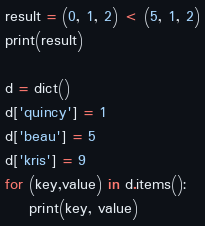<code> <loc_0><loc_0><loc_500><loc_500><_Python_>result = (0, 1, 2) < (5, 1, 2)
print(result)

d = dict()
d['quincy'] = 1
d['beau'] = 5
d['kris'] = 9
for (key,value) in d.items():
    print(key, value)</code> 